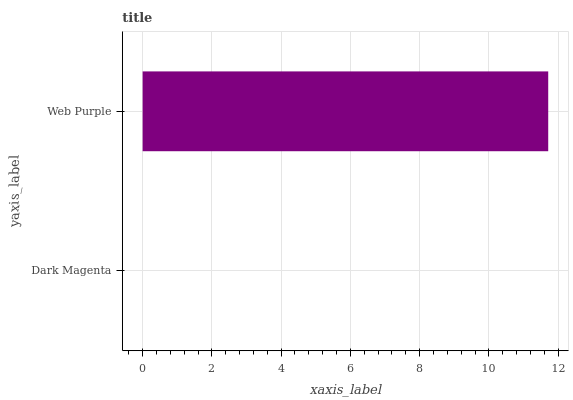Is Dark Magenta the minimum?
Answer yes or no. Yes. Is Web Purple the maximum?
Answer yes or no. Yes. Is Web Purple the minimum?
Answer yes or no. No. Is Web Purple greater than Dark Magenta?
Answer yes or no. Yes. Is Dark Magenta less than Web Purple?
Answer yes or no. Yes. Is Dark Magenta greater than Web Purple?
Answer yes or no. No. Is Web Purple less than Dark Magenta?
Answer yes or no. No. Is Web Purple the high median?
Answer yes or no. Yes. Is Dark Magenta the low median?
Answer yes or no. Yes. Is Dark Magenta the high median?
Answer yes or no. No. Is Web Purple the low median?
Answer yes or no. No. 